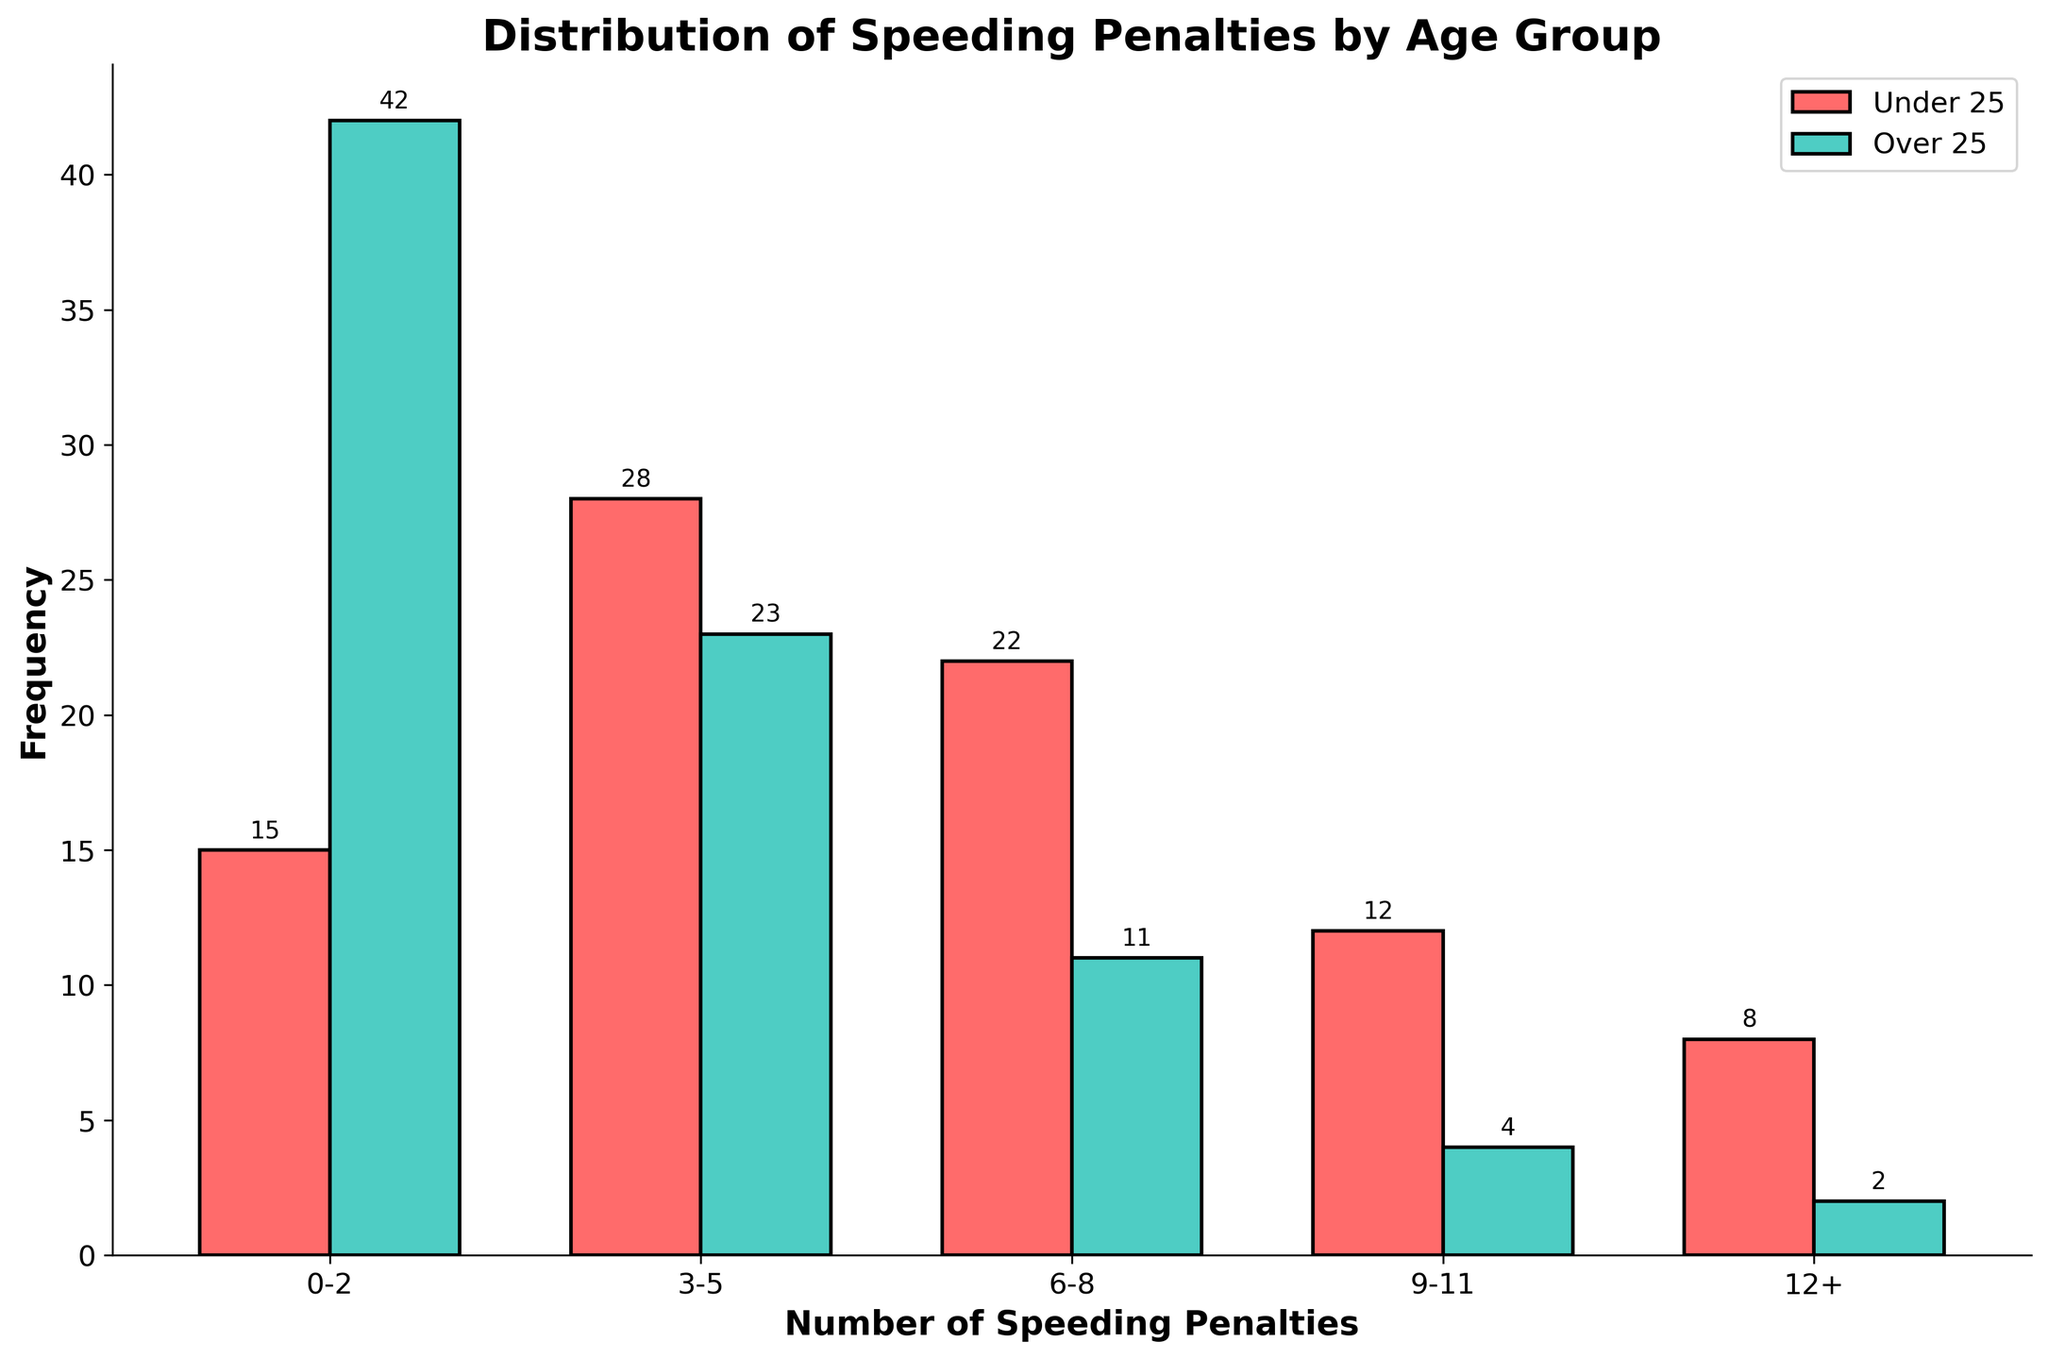What's the title of the figure? The title is usually displayed at the top of the figure. By reading this, we can understand the overall subject of the data visualization.
Answer: Distribution of Speeding Penalties by Age Group What does the x-axis represent? The x-axis shows the categories of speeding penalties, representing different ranges in number of penalties incurred. These are useful for understanding the distribution of penalties.
Answer: Number of Speeding Penalties What are the colors used to distinguish between the two age groups? Different colors are used for the bars representing the two age groups to make it easier to compare them visually. By noting the colors, we can identify the specific age group more clearly.
Answer: Red for Under 25 and Teal for Over 25 How many speeding penalties have drivers under 25 received in the range of 3-5 penalties? By observing the bar for the 3-5 penalties range under the Under 25 category, we can determine the frequency of penalties. The height and the label on the bar helps in this determination.
Answer: 28 What is the difference in the frequency of penalties in the 0-2 range between drivers under 25 and over 25? First identify the frequencies for both age groups in the 0-2 penalties range. Then subtract the smaller value from the larger one to get the difference.
Answer: 42 - 15 = 27 Which age group shows a higher frequency of penalties in the 6-8 range? By comparing the heights and labels of the bars for the two age groups in the 6-8 penalties range, we can determine which one is higher.
Answer: Under 25 How does the frequency of penalties for drivers under 25 in the 9-11 range compare to those in the 12+ range? By comparing the heights and labels of the bars for the Under 25 category in the 9-11 range to the 12+ range, we can see which has a larger frequency.
Answer: 12 vs. 8, so 9-11 is higher What is the total frequency of penalties for drivers over 25? By summing up the frequencies in all penalty ranges for the age group Over 25, we can get the total frequency.
Answer: 42 + 23 + 11 + 4 + 2 = 82 In which penalty range do drivers over 25 have the least frequency? Observing the bars for the Over 25 category across all ranges, the bar with the smallest height indicates the least frequency.
Answer: 12+ range Do drivers under 25 or over 25 have more occurrences in the high penalty range of 12+? Comparing the heights of the bars in the 12+ penalties range for both age groups, we can see which one has more occurrences.
Answer: Under 25 